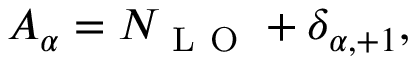Convert formula to latex. <formula><loc_0><loc_0><loc_500><loc_500>A _ { \alpha } = N _ { L O } + \delta _ { \alpha , + 1 } ,</formula> 